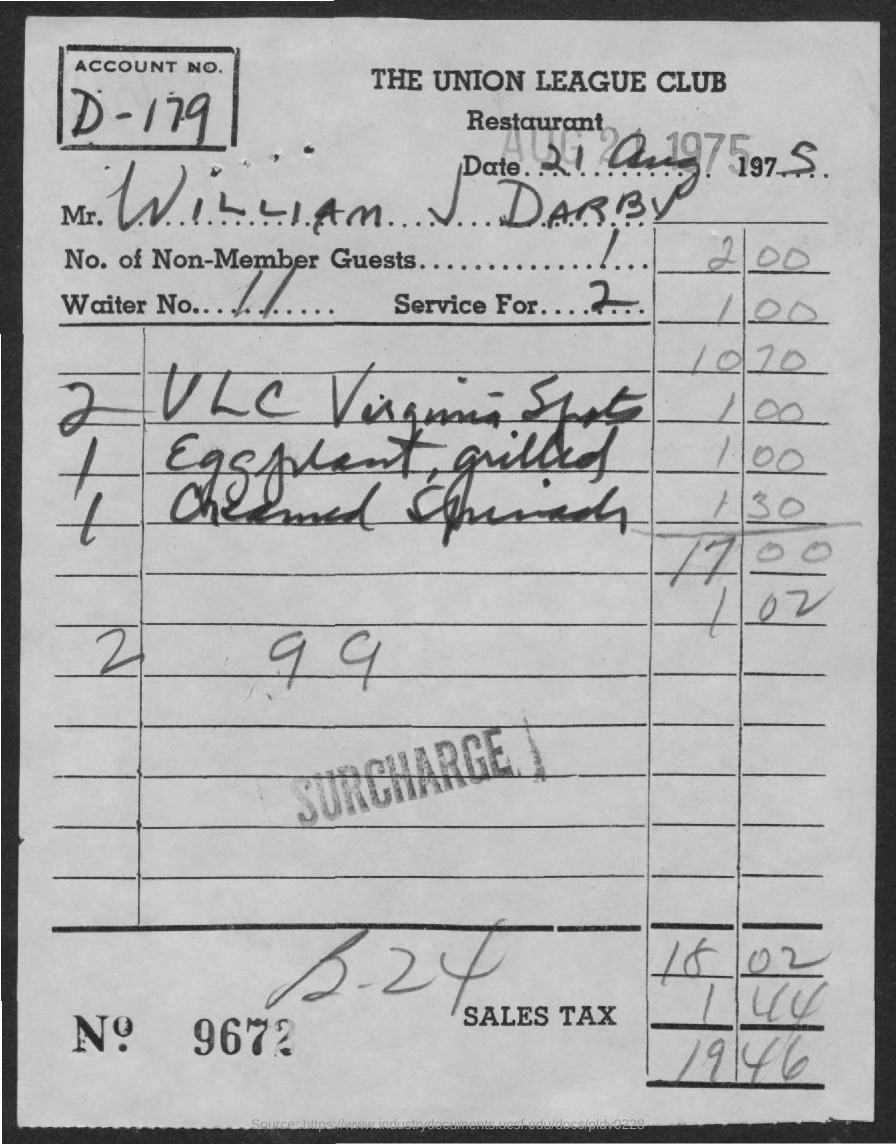What is name of the restaurant?
Keep it short and to the point. The Union League Club. What is the date on the bill?
Make the answer very short. 21 Aug 1975. What is the name of customer on the bill?
Your answer should be compact. William J Darby. What is the waiter no.?
Your response must be concise. 11. How many non- member guests are there?
Give a very brief answer. 1. To how many is the service for?
Provide a short and direct response. 2. What is the bill no.?
Provide a short and direct response. 9672. What is the sales tax charged?
Offer a very short reply. 1 44. What is total amount?
Your response must be concise. 19 46. 